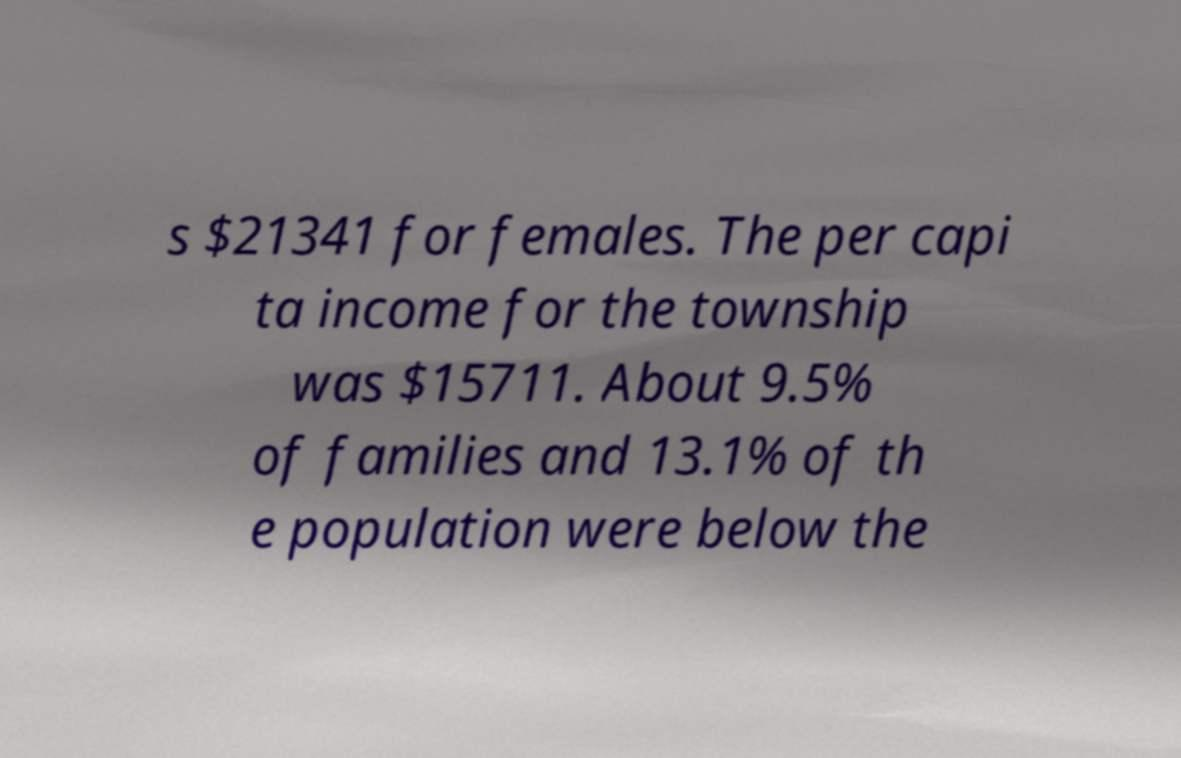Please identify and transcribe the text found in this image. s $21341 for females. The per capi ta income for the township was $15711. About 9.5% of families and 13.1% of th e population were below the 